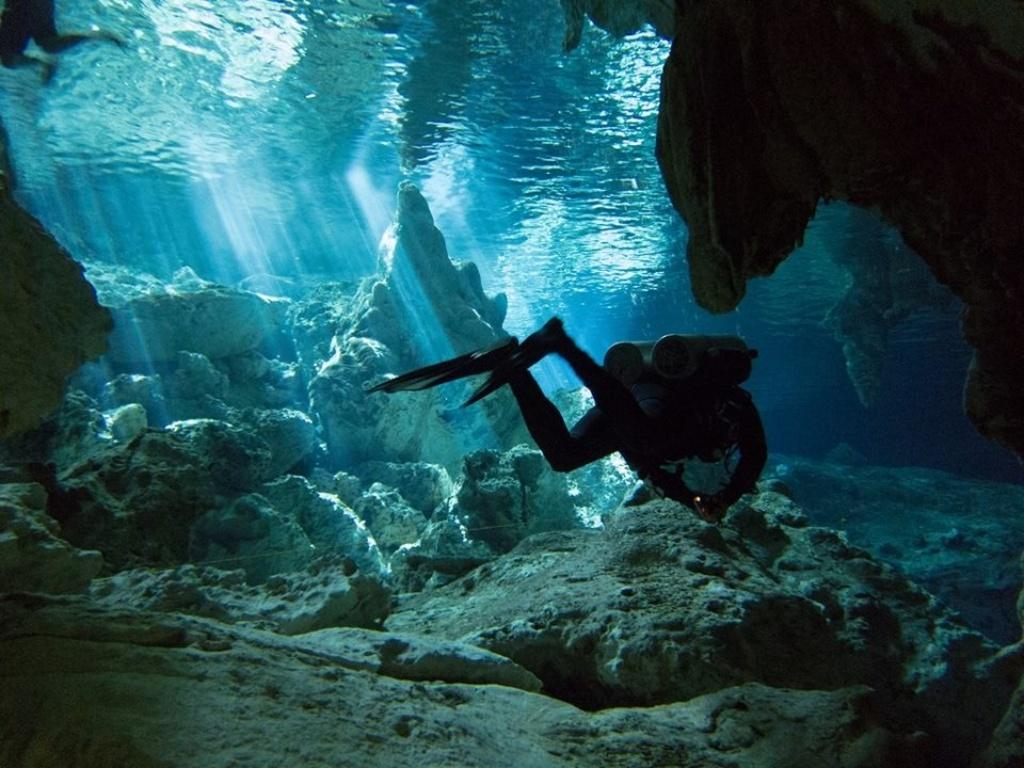What type of environment is shown in the image? The image depicts an underwater scene. What is the person in the image doing? The person is swimming in the image. What equipment is the person wearing? The person is wearing cylinders, which are likely scuba diving gear. What can be seen in the background of the image? There are rocks visible in the image. Can you see a flock of birds flying above the water in the image? No, there are no birds or flocks visible in the underwater scene. Is there any bread floating on the surface of the water in the image? No, there is no bread present in the underwater scene. 